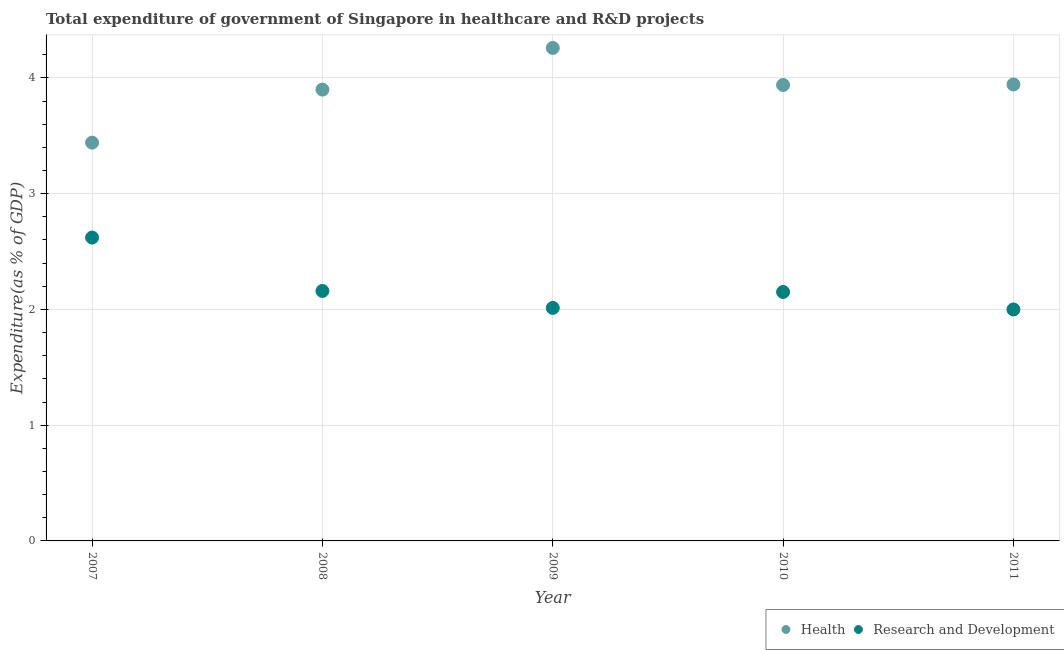How many different coloured dotlines are there?
Make the answer very short. 2. What is the expenditure in healthcare in 2010?
Offer a very short reply. 3.94. Across all years, what is the maximum expenditure in r&d?
Give a very brief answer. 2.62. Across all years, what is the minimum expenditure in healthcare?
Your response must be concise. 3.44. What is the total expenditure in r&d in the graph?
Give a very brief answer. 10.94. What is the difference between the expenditure in r&d in 2009 and that in 2010?
Your answer should be very brief. -0.14. What is the difference between the expenditure in r&d in 2011 and the expenditure in healthcare in 2010?
Offer a very short reply. -1.94. What is the average expenditure in healthcare per year?
Your answer should be very brief. 3.9. In the year 2011, what is the difference between the expenditure in healthcare and expenditure in r&d?
Offer a terse response. 1.94. In how many years, is the expenditure in healthcare greater than 4 %?
Offer a very short reply. 1. What is the ratio of the expenditure in r&d in 2009 to that in 2010?
Ensure brevity in your answer.  0.94. Is the difference between the expenditure in r&d in 2009 and 2011 greater than the difference between the expenditure in healthcare in 2009 and 2011?
Provide a succinct answer. No. What is the difference between the highest and the second highest expenditure in r&d?
Give a very brief answer. 0.46. What is the difference between the highest and the lowest expenditure in healthcare?
Make the answer very short. 0.82. In how many years, is the expenditure in healthcare greater than the average expenditure in healthcare taken over all years?
Make the answer very short. 4. Is the sum of the expenditure in healthcare in 2008 and 2010 greater than the maximum expenditure in r&d across all years?
Provide a succinct answer. Yes. Is the expenditure in r&d strictly less than the expenditure in healthcare over the years?
Your response must be concise. Yes. How many dotlines are there?
Your response must be concise. 2. Are the values on the major ticks of Y-axis written in scientific E-notation?
Keep it short and to the point. No. How many legend labels are there?
Offer a very short reply. 2. What is the title of the graph?
Give a very brief answer. Total expenditure of government of Singapore in healthcare and R&D projects. Does "Number of departures" appear as one of the legend labels in the graph?
Provide a short and direct response. No. What is the label or title of the X-axis?
Your answer should be very brief. Year. What is the label or title of the Y-axis?
Your response must be concise. Expenditure(as % of GDP). What is the Expenditure(as % of GDP) in Health in 2007?
Provide a short and direct response. 3.44. What is the Expenditure(as % of GDP) in Research and Development in 2007?
Provide a short and direct response. 2.62. What is the Expenditure(as % of GDP) of Health in 2008?
Provide a succinct answer. 3.9. What is the Expenditure(as % of GDP) in Research and Development in 2008?
Your answer should be very brief. 2.16. What is the Expenditure(as % of GDP) in Health in 2009?
Your answer should be compact. 4.26. What is the Expenditure(as % of GDP) of Research and Development in 2009?
Offer a very short reply. 2.01. What is the Expenditure(as % of GDP) in Health in 2010?
Your answer should be very brief. 3.94. What is the Expenditure(as % of GDP) in Research and Development in 2010?
Your answer should be very brief. 2.15. What is the Expenditure(as % of GDP) in Health in 2011?
Provide a succinct answer. 3.94. What is the Expenditure(as % of GDP) in Research and Development in 2011?
Keep it short and to the point. 2. Across all years, what is the maximum Expenditure(as % of GDP) in Health?
Your response must be concise. 4.26. Across all years, what is the maximum Expenditure(as % of GDP) in Research and Development?
Your response must be concise. 2.62. Across all years, what is the minimum Expenditure(as % of GDP) of Health?
Provide a short and direct response. 3.44. Across all years, what is the minimum Expenditure(as % of GDP) in Research and Development?
Your answer should be very brief. 2. What is the total Expenditure(as % of GDP) of Health in the graph?
Your answer should be very brief. 19.48. What is the total Expenditure(as % of GDP) of Research and Development in the graph?
Provide a short and direct response. 10.94. What is the difference between the Expenditure(as % of GDP) of Health in 2007 and that in 2008?
Provide a short and direct response. -0.46. What is the difference between the Expenditure(as % of GDP) of Research and Development in 2007 and that in 2008?
Provide a short and direct response. 0.46. What is the difference between the Expenditure(as % of GDP) of Health in 2007 and that in 2009?
Your answer should be very brief. -0.82. What is the difference between the Expenditure(as % of GDP) of Research and Development in 2007 and that in 2009?
Your answer should be very brief. 0.61. What is the difference between the Expenditure(as % of GDP) of Health in 2007 and that in 2010?
Offer a terse response. -0.5. What is the difference between the Expenditure(as % of GDP) of Research and Development in 2007 and that in 2010?
Your response must be concise. 0.47. What is the difference between the Expenditure(as % of GDP) in Health in 2007 and that in 2011?
Ensure brevity in your answer.  -0.5. What is the difference between the Expenditure(as % of GDP) in Research and Development in 2007 and that in 2011?
Your response must be concise. 0.62. What is the difference between the Expenditure(as % of GDP) of Health in 2008 and that in 2009?
Your answer should be very brief. -0.36. What is the difference between the Expenditure(as % of GDP) of Research and Development in 2008 and that in 2009?
Your response must be concise. 0.15. What is the difference between the Expenditure(as % of GDP) of Health in 2008 and that in 2010?
Keep it short and to the point. -0.04. What is the difference between the Expenditure(as % of GDP) of Research and Development in 2008 and that in 2010?
Give a very brief answer. 0.01. What is the difference between the Expenditure(as % of GDP) in Health in 2008 and that in 2011?
Offer a terse response. -0.04. What is the difference between the Expenditure(as % of GDP) in Research and Development in 2008 and that in 2011?
Provide a short and direct response. 0.16. What is the difference between the Expenditure(as % of GDP) in Health in 2009 and that in 2010?
Keep it short and to the point. 0.32. What is the difference between the Expenditure(as % of GDP) in Research and Development in 2009 and that in 2010?
Offer a very short reply. -0.14. What is the difference between the Expenditure(as % of GDP) in Health in 2009 and that in 2011?
Offer a terse response. 0.32. What is the difference between the Expenditure(as % of GDP) in Research and Development in 2009 and that in 2011?
Provide a short and direct response. 0.01. What is the difference between the Expenditure(as % of GDP) in Health in 2010 and that in 2011?
Keep it short and to the point. -0. What is the difference between the Expenditure(as % of GDP) in Research and Development in 2010 and that in 2011?
Provide a succinct answer. 0.15. What is the difference between the Expenditure(as % of GDP) in Health in 2007 and the Expenditure(as % of GDP) in Research and Development in 2008?
Provide a short and direct response. 1.28. What is the difference between the Expenditure(as % of GDP) in Health in 2007 and the Expenditure(as % of GDP) in Research and Development in 2009?
Give a very brief answer. 1.43. What is the difference between the Expenditure(as % of GDP) in Health in 2007 and the Expenditure(as % of GDP) in Research and Development in 2010?
Give a very brief answer. 1.29. What is the difference between the Expenditure(as % of GDP) in Health in 2007 and the Expenditure(as % of GDP) in Research and Development in 2011?
Ensure brevity in your answer.  1.44. What is the difference between the Expenditure(as % of GDP) of Health in 2008 and the Expenditure(as % of GDP) of Research and Development in 2009?
Ensure brevity in your answer.  1.89. What is the difference between the Expenditure(as % of GDP) in Health in 2008 and the Expenditure(as % of GDP) in Research and Development in 2010?
Offer a terse response. 1.75. What is the difference between the Expenditure(as % of GDP) in Health in 2008 and the Expenditure(as % of GDP) in Research and Development in 2011?
Give a very brief answer. 1.9. What is the difference between the Expenditure(as % of GDP) of Health in 2009 and the Expenditure(as % of GDP) of Research and Development in 2010?
Give a very brief answer. 2.11. What is the difference between the Expenditure(as % of GDP) of Health in 2009 and the Expenditure(as % of GDP) of Research and Development in 2011?
Make the answer very short. 2.26. What is the difference between the Expenditure(as % of GDP) of Health in 2010 and the Expenditure(as % of GDP) of Research and Development in 2011?
Offer a very short reply. 1.94. What is the average Expenditure(as % of GDP) of Health per year?
Your response must be concise. 3.9. What is the average Expenditure(as % of GDP) of Research and Development per year?
Offer a very short reply. 2.19. In the year 2007, what is the difference between the Expenditure(as % of GDP) of Health and Expenditure(as % of GDP) of Research and Development?
Ensure brevity in your answer.  0.82. In the year 2008, what is the difference between the Expenditure(as % of GDP) of Health and Expenditure(as % of GDP) of Research and Development?
Give a very brief answer. 1.74. In the year 2009, what is the difference between the Expenditure(as % of GDP) in Health and Expenditure(as % of GDP) in Research and Development?
Offer a terse response. 2.25. In the year 2010, what is the difference between the Expenditure(as % of GDP) of Health and Expenditure(as % of GDP) of Research and Development?
Your answer should be compact. 1.79. In the year 2011, what is the difference between the Expenditure(as % of GDP) in Health and Expenditure(as % of GDP) in Research and Development?
Provide a short and direct response. 1.94. What is the ratio of the Expenditure(as % of GDP) of Health in 2007 to that in 2008?
Your answer should be compact. 0.88. What is the ratio of the Expenditure(as % of GDP) in Research and Development in 2007 to that in 2008?
Provide a short and direct response. 1.21. What is the ratio of the Expenditure(as % of GDP) in Health in 2007 to that in 2009?
Give a very brief answer. 0.81. What is the ratio of the Expenditure(as % of GDP) in Research and Development in 2007 to that in 2009?
Provide a short and direct response. 1.3. What is the ratio of the Expenditure(as % of GDP) in Health in 2007 to that in 2010?
Ensure brevity in your answer.  0.87. What is the ratio of the Expenditure(as % of GDP) in Research and Development in 2007 to that in 2010?
Ensure brevity in your answer.  1.22. What is the ratio of the Expenditure(as % of GDP) in Health in 2007 to that in 2011?
Keep it short and to the point. 0.87. What is the ratio of the Expenditure(as % of GDP) of Research and Development in 2007 to that in 2011?
Give a very brief answer. 1.31. What is the ratio of the Expenditure(as % of GDP) of Health in 2008 to that in 2009?
Offer a very short reply. 0.92. What is the ratio of the Expenditure(as % of GDP) of Research and Development in 2008 to that in 2009?
Provide a succinct answer. 1.07. What is the ratio of the Expenditure(as % of GDP) in Health in 2008 to that in 2010?
Offer a very short reply. 0.99. What is the ratio of the Expenditure(as % of GDP) in Health in 2008 to that in 2011?
Keep it short and to the point. 0.99. What is the ratio of the Expenditure(as % of GDP) of Research and Development in 2008 to that in 2011?
Provide a short and direct response. 1.08. What is the ratio of the Expenditure(as % of GDP) in Health in 2009 to that in 2010?
Your answer should be compact. 1.08. What is the ratio of the Expenditure(as % of GDP) in Research and Development in 2009 to that in 2010?
Provide a short and direct response. 0.94. What is the ratio of the Expenditure(as % of GDP) of Health in 2009 to that in 2011?
Make the answer very short. 1.08. What is the ratio of the Expenditure(as % of GDP) in Research and Development in 2009 to that in 2011?
Provide a short and direct response. 1.01. What is the ratio of the Expenditure(as % of GDP) in Health in 2010 to that in 2011?
Make the answer very short. 1. What is the ratio of the Expenditure(as % of GDP) of Research and Development in 2010 to that in 2011?
Your answer should be compact. 1.08. What is the difference between the highest and the second highest Expenditure(as % of GDP) of Health?
Your response must be concise. 0.32. What is the difference between the highest and the second highest Expenditure(as % of GDP) of Research and Development?
Your response must be concise. 0.46. What is the difference between the highest and the lowest Expenditure(as % of GDP) in Health?
Provide a succinct answer. 0.82. What is the difference between the highest and the lowest Expenditure(as % of GDP) in Research and Development?
Keep it short and to the point. 0.62. 